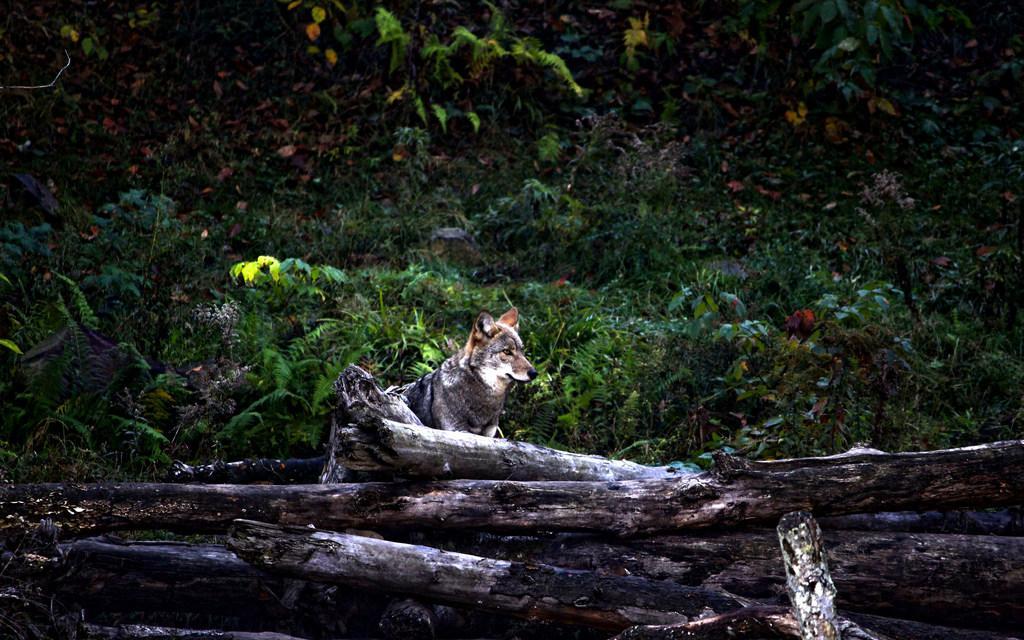Describe this image in one or two sentences. In this image I can see log of wood and behind it I can see a dog. I can also see few plants in the background. 